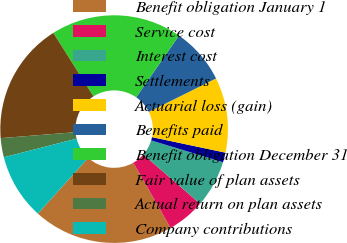Convert chart. <chart><loc_0><loc_0><loc_500><loc_500><pie_chart><fcel>Benefit obligation January 1<fcel>Service cost<fcel>Interest cost<fcel>Settlements<fcel>Actuarial loss (gain)<fcel>Benefits paid<fcel>Benefit obligation December 31<fcel>Fair value of plan assets<fcel>Actual return on plan assets<fcel>Company contributions<nl><fcel>19.95%<fcel>5.36%<fcel>6.68%<fcel>1.38%<fcel>10.66%<fcel>8.01%<fcel>18.62%<fcel>17.29%<fcel>2.71%<fcel>9.34%<nl></chart> 